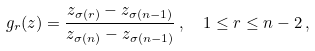Convert formula to latex. <formula><loc_0><loc_0><loc_500><loc_500>g _ { r } ( z ) = \frac { z _ { \sigma ( r ) } - z _ { \sigma ( n - 1 ) } } { z _ { \sigma ( n ) } - z _ { \sigma ( n - 1 ) } } \, , \ \ 1 \leq r \leq n - 2 \, ,</formula> 